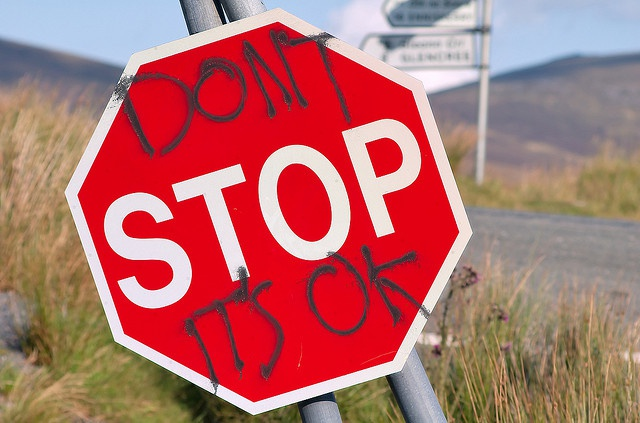Describe the objects in this image and their specific colors. I can see a stop sign in lightblue, red, lightgray, maroon, and brown tones in this image. 